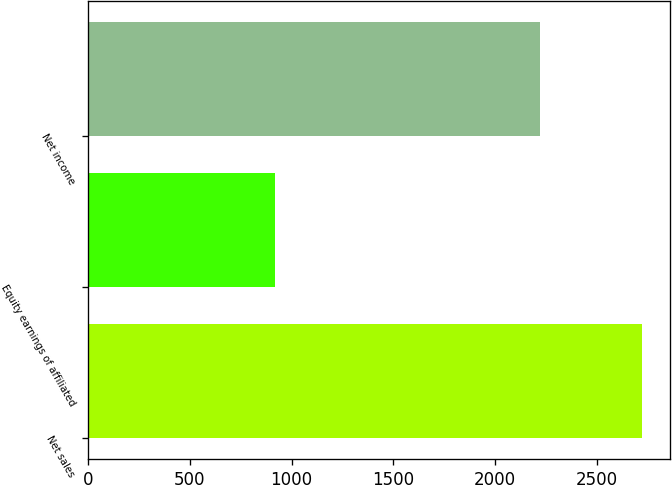Convert chart. <chart><loc_0><loc_0><loc_500><loc_500><bar_chart><fcel>Net sales<fcel>Equity earnings of affiliated<fcel>Net income<nl><fcel>2724<fcel>916<fcel>2221<nl></chart> 